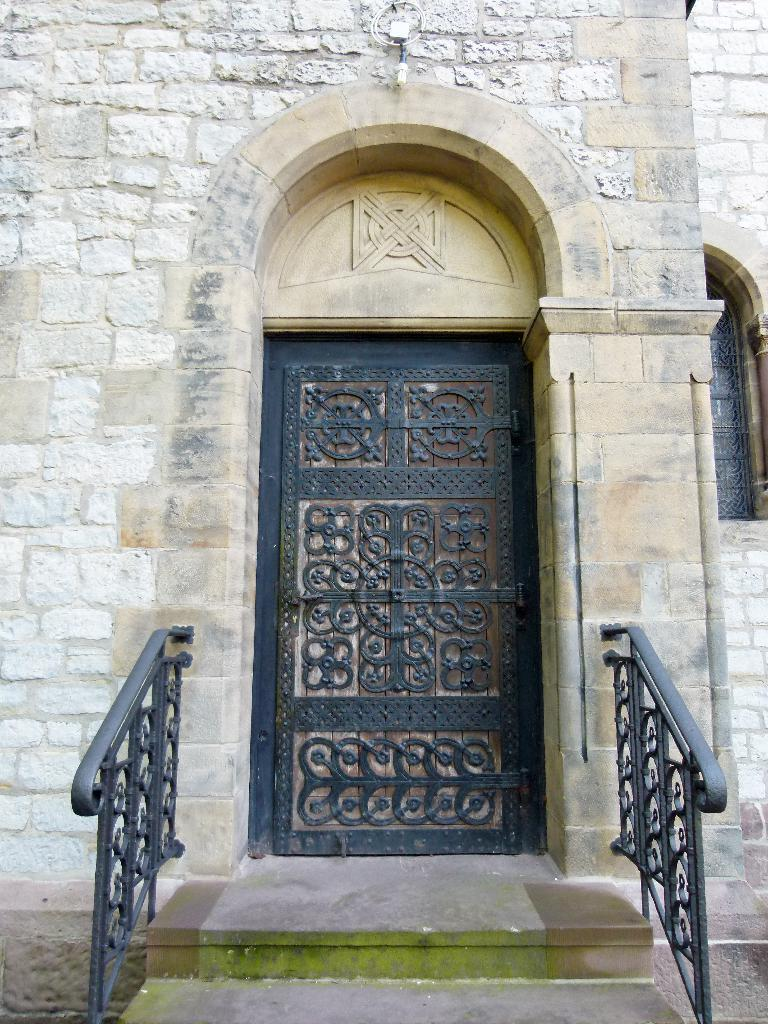What can be seen at the front of the image? There are steps and railings in the front of the image. What is located in the background of the image? There is a door, a wall, and a window in the background of the image. What might be used for entering or exiting the building in the image? The door in the background of the image might be used for entering or exiting the building. How many fans are visible in the image? There are no fans present in the image. Are there any slaves depicted in the image? There is no depiction of slaves in the image. 